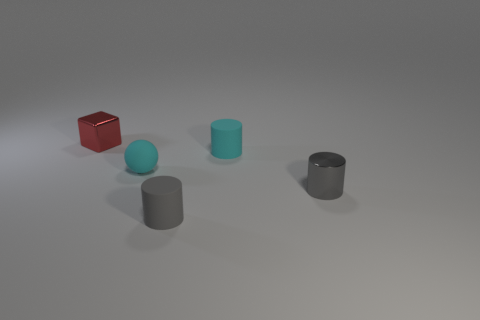Is there anything else that has the same shape as the red metal thing?
Provide a short and direct response. No. Are there an equal number of cylinders to the right of the small gray matte object and small metal objects that are behind the small shiny cylinder?
Your answer should be compact. No. How many objects have the same size as the rubber ball?
Keep it short and to the point. 4. How many yellow objects are matte cylinders or tiny objects?
Provide a short and direct response. 0. Are there an equal number of cyan matte objects that are in front of the metallic cylinder and cyan rubber cylinders?
Give a very brief answer. No. How big is the metal object on the right side of the tiny gray matte cylinder?
Make the answer very short. Small. How many red metal things are the same shape as the small gray matte object?
Your answer should be compact. 0. There is a object that is both behind the cyan sphere and on the right side of the red shiny cube; what material is it made of?
Provide a short and direct response. Rubber. Are the tiny cyan cylinder and the cyan sphere made of the same material?
Your response must be concise. Yes. What number of small red metal blocks are there?
Keep it short and to the point. 1. 